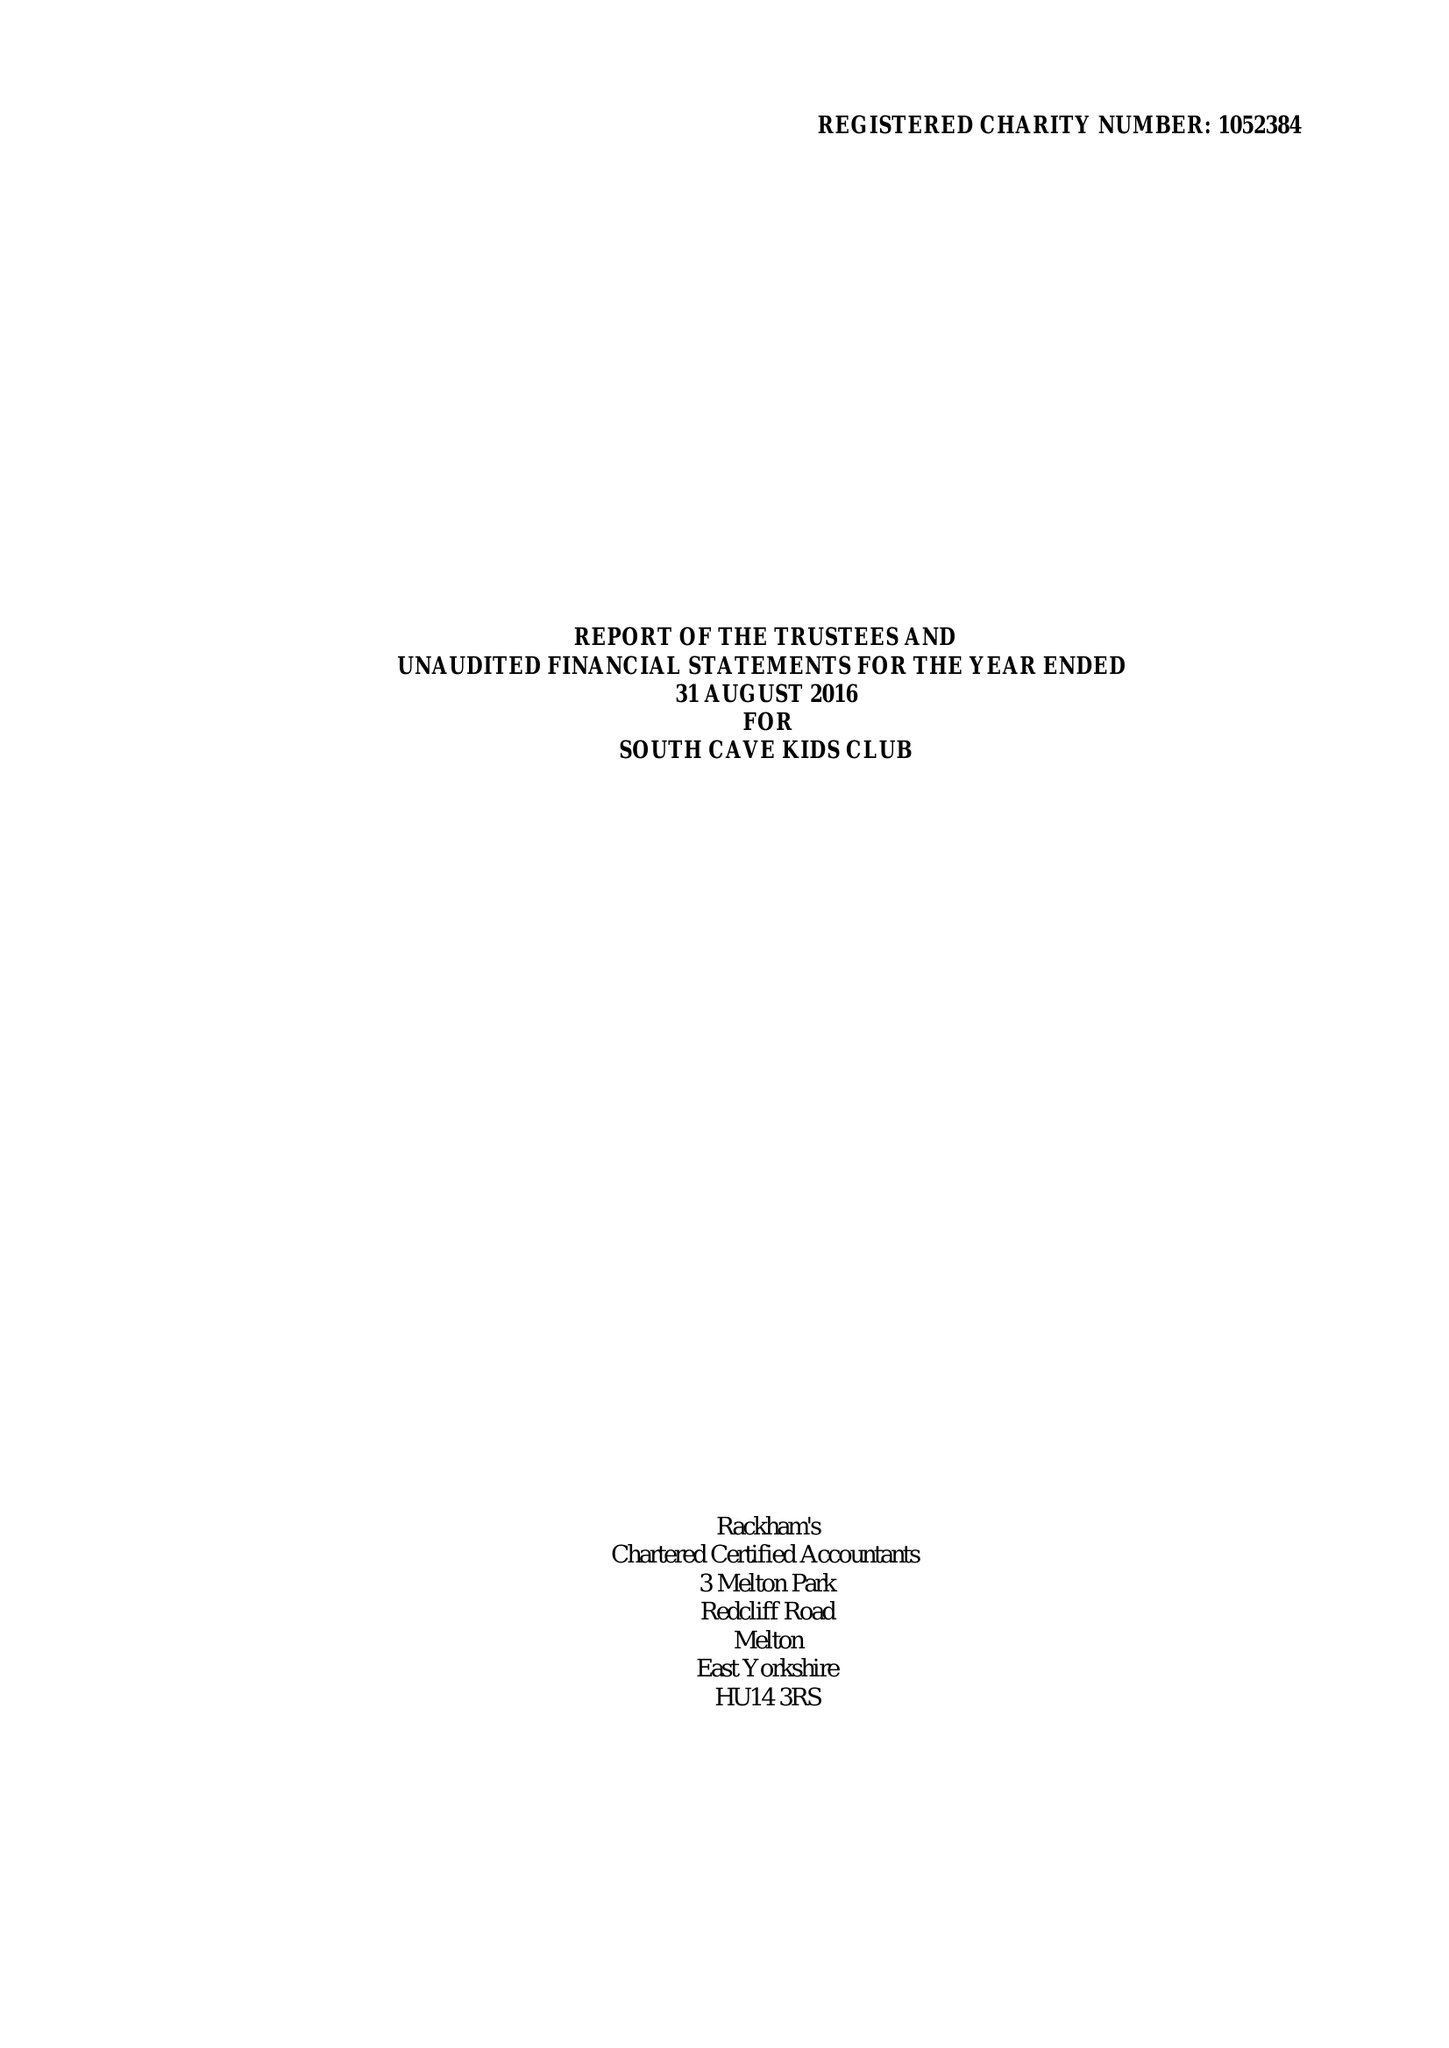What is the value for the report_date?
Answer the question using a single word or phrase. 2016-08-31 